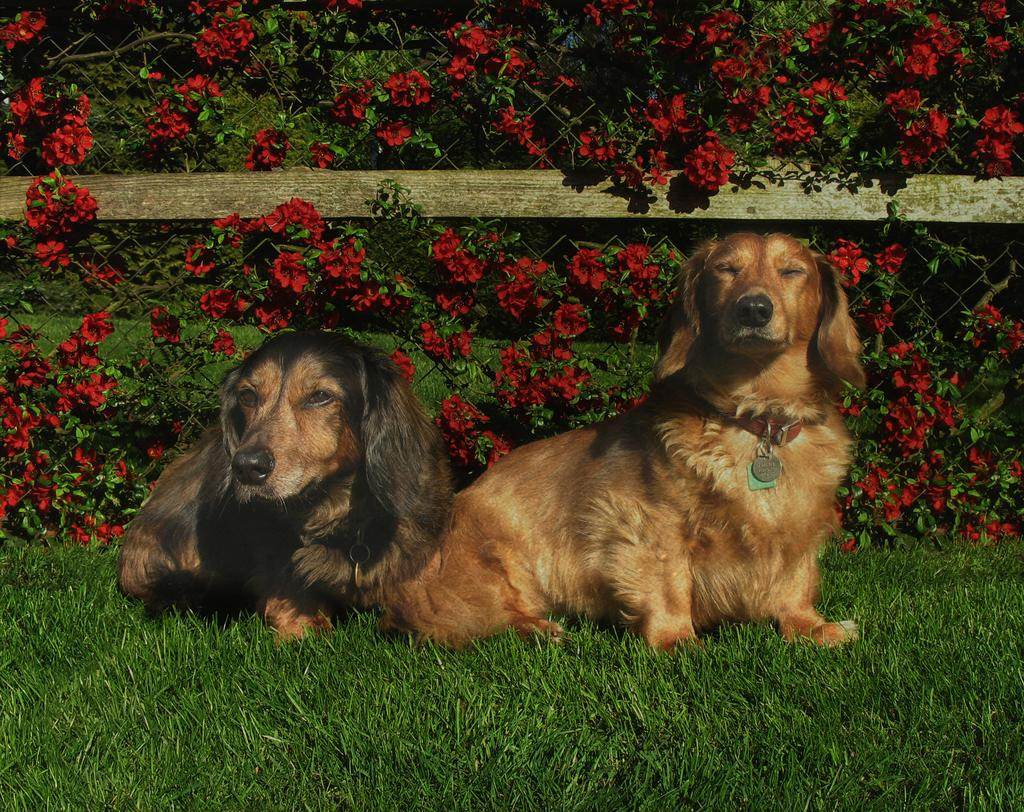What type of animals can be seen in the image? There are dogs on the grass in the image. What is the mesh covering in the image? The mesh is covering flowers and leaves. What can be seen through the mesh? Trees are visible through the mesh. What type of cactus can be seen on the floor in the image? There is no cactus present on the floor in the image. 